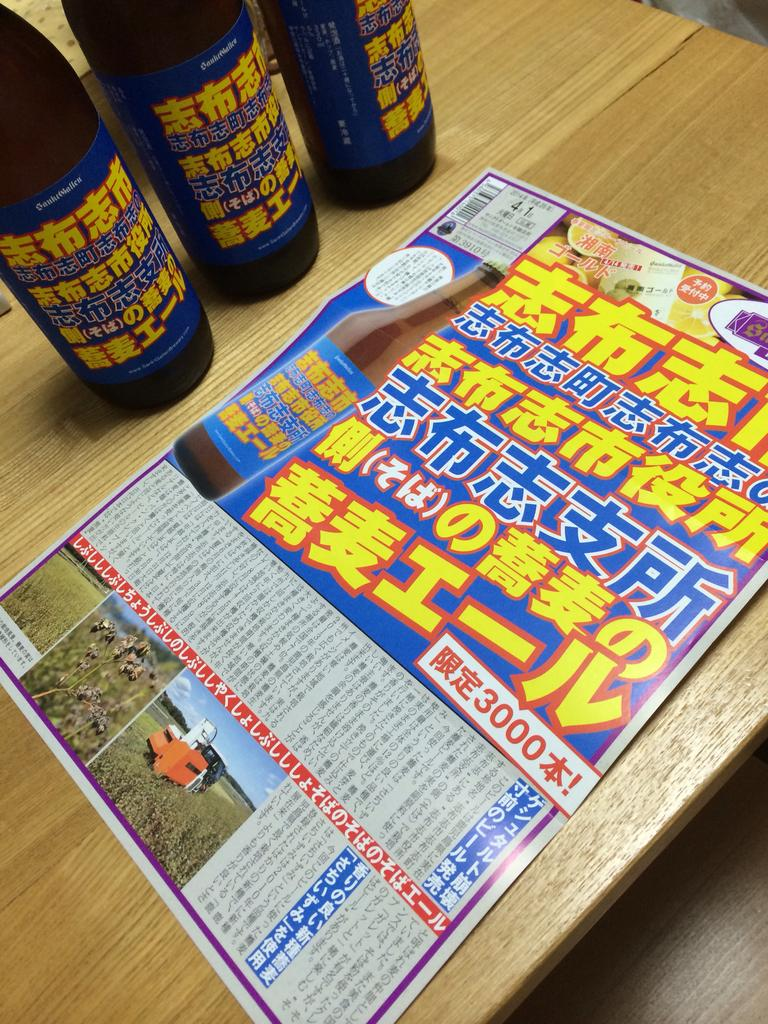<image>
Present a compact description of the photo's key features. A newpaper in oriental script that has the number 3000 on it. 